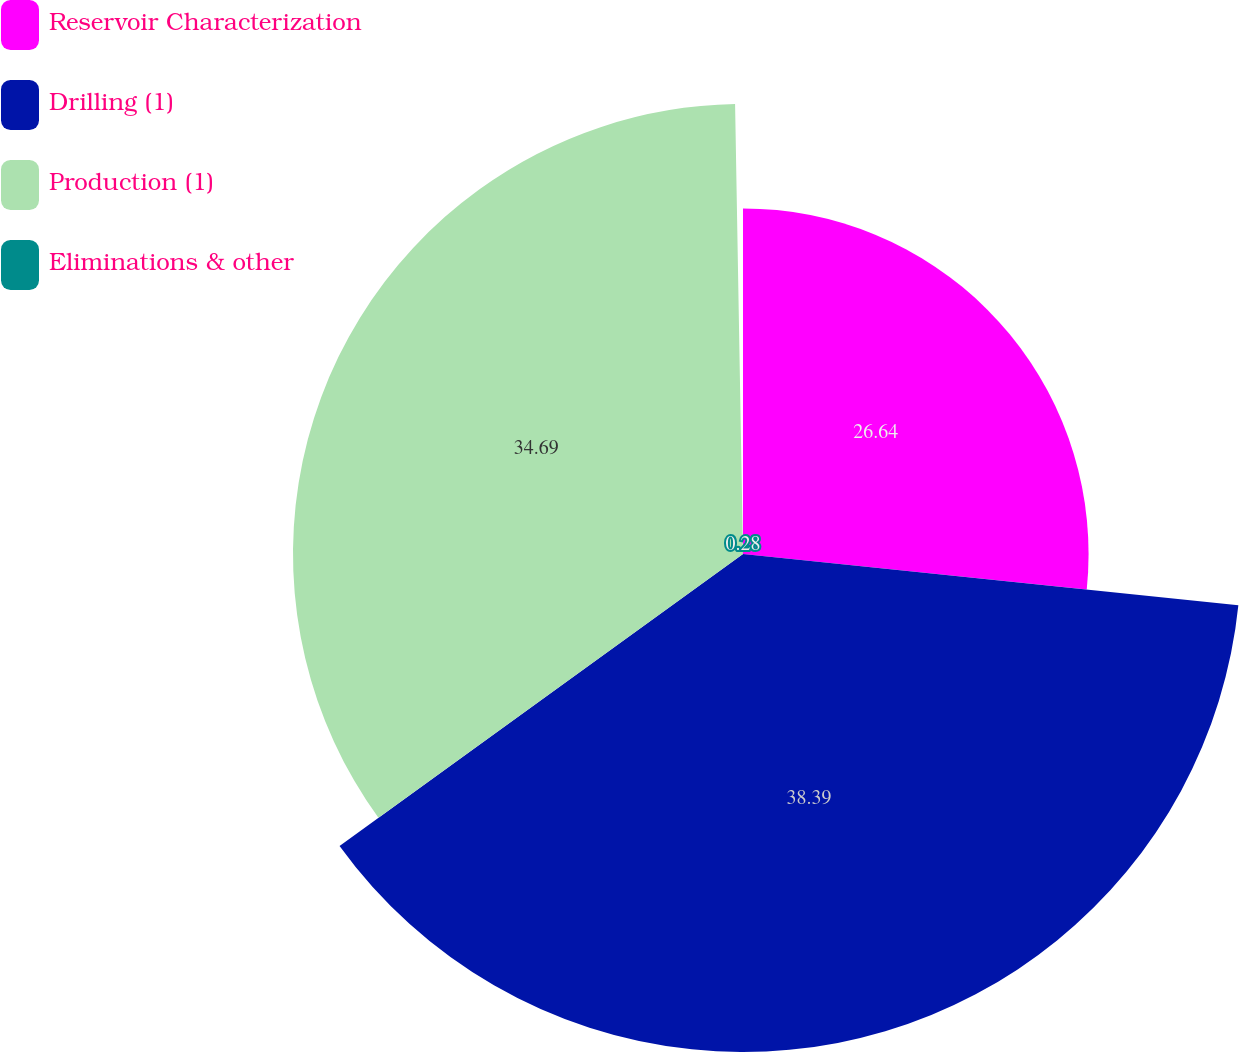Convert chart to OTSL. <chart><loc_0><loc_0><loc_500><loc_500><pie_chart><fcel>Reservoir Characterization<fcel>Drilling (1)<fcel>Production (1)<fcel>Eliminations & other<nl><fcel>26.64%<fcel>38.39%<fcel>34.69%<fcel>0.28%<nl></chart> 